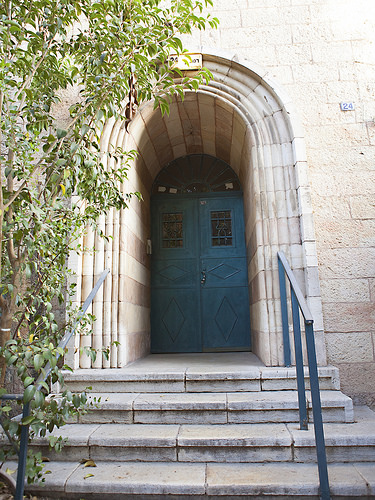<image>
Is there a railing in front of the sign? Yes. The railing is positioned in front of the sign, appearing closer to the camera viewpoint. 